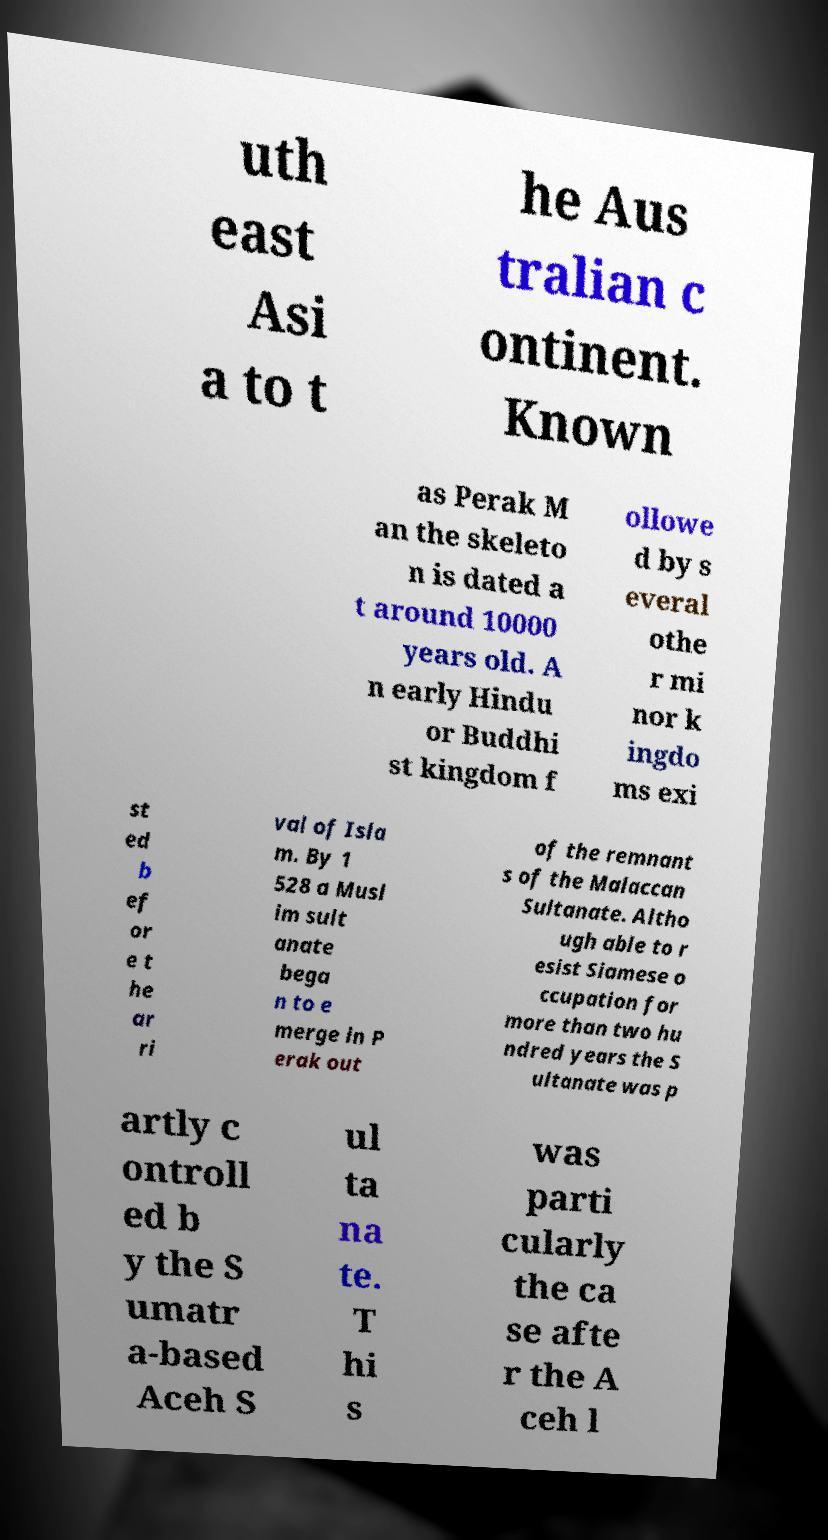Can you read and provide the text displayed in the image?This photo seems to have some interesting text. Can you extract and type it out for me? uth east Asi a to t he Aus tralian c ontinent. Known as Perak M an the skeleto n is dated a t around 10000 years old. A n early Hindu or Buddhi st kingdom f ollowe d by s everal othe r mi nor k ingdo ms exi st ed b ef or e t he ar ri val of Isla m. By 1 528 a Musl im sult anate bega n to e merge in P erak out of the remnant s of the Malaccan Sultanate. Altho ugh able to r esist Siamese o ccupation for more than two hu ndred years the S ultanate was p artly c ontroll ed b y the S umatr a-based Aceh S ul ta na te. T hi s was parti cularly the ca se afte r the A ceh l 